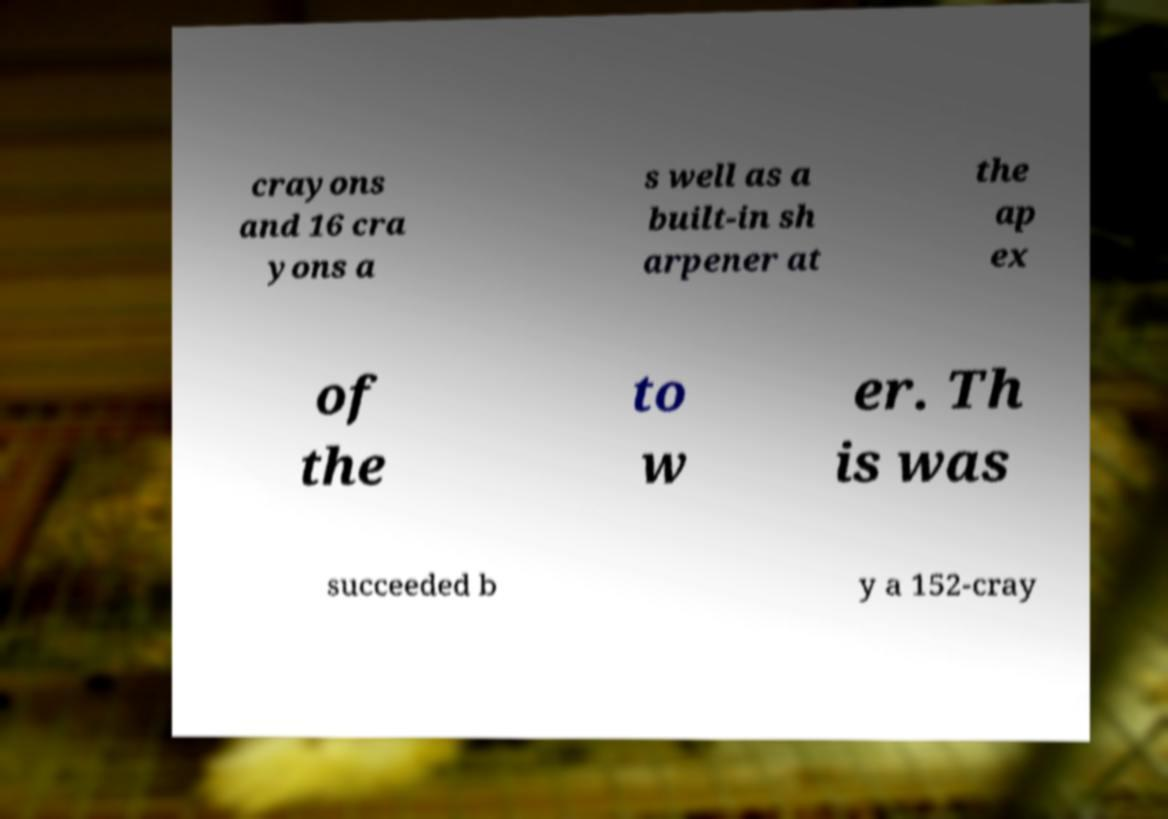Please identify and transcribe the text found in this image. crayons and 16 cra yons a s well as a built-in sh arpener at the ap ex of the to w er. Th is was succeeded b y a 152-cray 